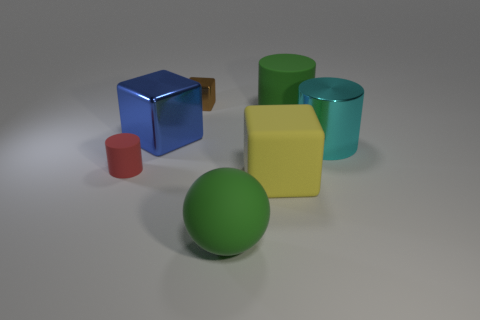Subtract all shiny blocks. How many blocks are left? 1 Add 2 matte cylinders. How many objects exist? 9 Subtract all cylinders. How many objects are left? 4 Subtract 1 cubes. How many cubes are left? 2 Subtract all green cylinders. How many cylinders are left? 2 Subtract all cyan spheres. Subtract all yellow cylinders. How many spheres are left? 1 Subtract all purple cubes. How many red cylinders are left? 1 Subtract all blue metal cylinders. Subtract all big yellow blocks. How many objects are left? 6 Add 4 large green cylinders. How many large green cylinders are left? 5 Add 5 brown things. How many brown things exist? 6 